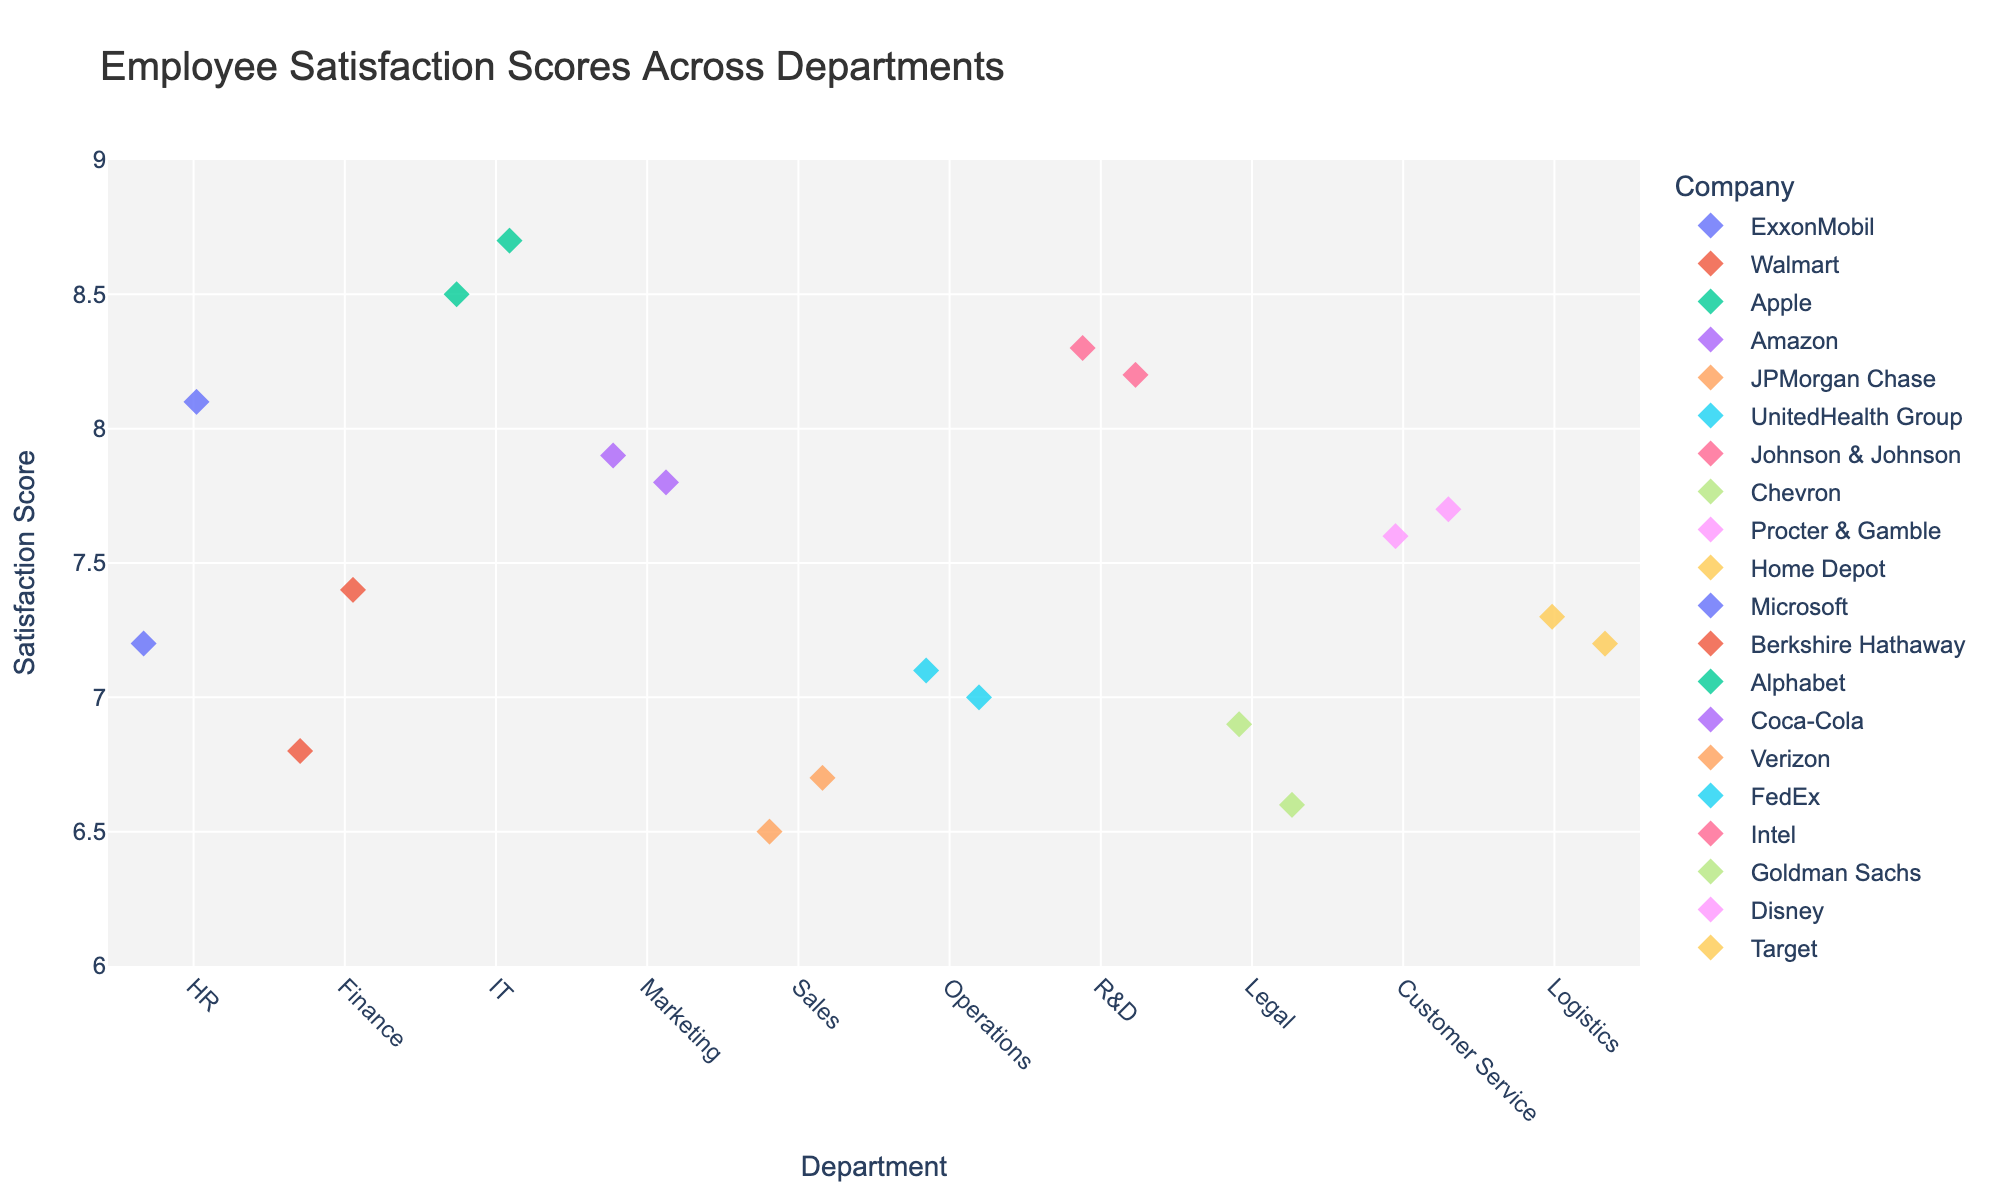How many departments are represented in the plot? Count the unique departments displayed on the x-axis. There are 10 departments: HR, Finance, IT, Marketing, Sales, Operations, R&D, Legal, Customer Service, and Logistics.
Answer: 10 Which department has the highest satisfaction score? Look at the y-axis values and find the highest point for each department. IT has the highest score at 8.7.
Answer: IT What is the average satisfaction score for the HR department? Identify the scores for HR and calculate the average. Scores: 7.2, 8.1. Average: (7.2 + 8.1)/2 = 7.65
Answer: 7.65 Which department has the most diverse set of satisfaction scores? Observe the spread and jitter of points for each department. Legal shows a wider spread of satisfaction scores compared to others.
Answer: Legal Between IT and Finance, which has a higher minimum satisfaction score? Look at the lowest points for IT and Finance. IT's minimum score is 8.5 and Finance's is 6.8.
Answer: IT What is the range of satisfaction scores for the R&D department? Find the highest and lowest scores in R&D. Highest: 8.3, Lowest: 8.2. Range: 8.3 - 8.2 = 0.1
Answer: 0.1 What is the median satisfaction score for the Marketing department? Sort the scores for Marketing: 7.8, 7.9. Since there are two data points, the median is the average of these two. (7.8 + 7.9)/2 = 7.85
Answer: 7.85 Is there any department where all companies have scores above 7? Check each department for the lowest score. R&D (8.2 and 8.3) and IT (8.5 and 8.7) have scores above 7 for all companies.
Answer: Yes Which company has the highest satisfaction score in the Customer Service department? Look at the company names and corresponding scores in Customer Service. Disney (7.7) vs. Procter & Gamble (7.6). Disney has the highest score.
Answer: Disney 